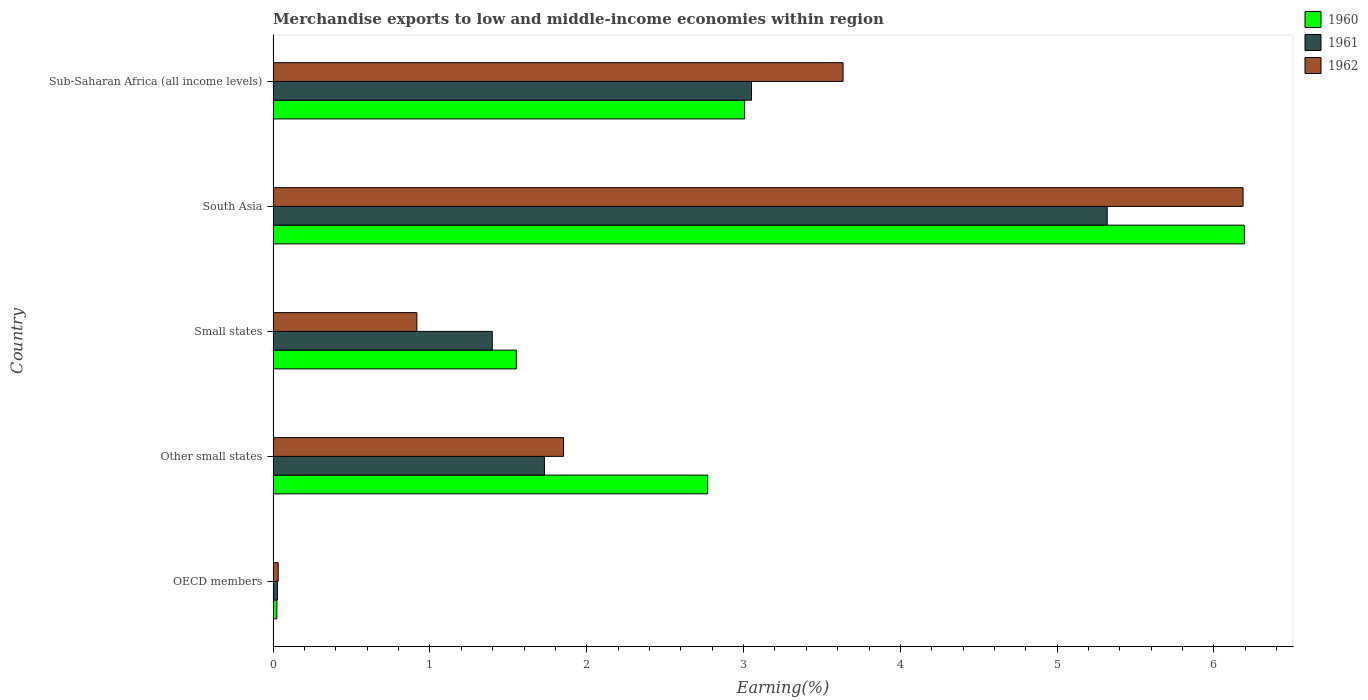How many different coloured bars are there?
Provide a succinct answer. 3. Are the number of bars per tick equal to the number of legend labels?
Your answer should be compact. Yes. Are the number of bars on each tick of the Y-axis equal?
Offer a terse response. Yes. What is the percentage of amount earned from merchandise exports in 1962 in South Asia?
Your response must be concise. 6.19. Across all countries, what is the maximum percentage of amount earned from merchandise exports in 1960?
Make the answer very short. 6.19. Across all countries, what is the minimum percentage of amount earned from merchandise exports in 1961?
Make the answer very short. 0.03. What is the total percentage of amount earned from merchandise exports in 1960 in the graph?
Keep it short and to the point. 13.55. What is the difference between the percentage of amount earned from merchandise exports in 1960 in OECD members and that in South Asia?
Ensure brevity in your answer.  -6.17. What is the difference between the percentage of amount earned from merchandise exports in 1960 in Other small states and the percentage of amount earned from merchandise exports in 1961 in South Asia?
Keep it short and to the point. -2.55. What is the average percentage of amount earned from merchandise exports in 1960 per country?
Provide a short and direct response. 2.71. What is the difference between the percentage of amount earned from merchandise exports in 1962 and percentage of amount earned from merchandise exports in 1961 in OECD members?
Your response must be concise. 0. In how many countries, is the percentage of amount earned from merchandise exports in 1962 greater than 3.4 %?
Keep it short and to the point. 2. What is the ratio of the percentage of amount earned from merchandise exports in 1962 in OECD members to that in South Asia?
Provide a short and direct response. 0.01. Is the percentage of amount earned from merchandise exports in 1962 in Other small states less than that in Sub-Saharan Africa (all income levels)?
Provide a succinct answer. Yes. What is the difference between the highest and the second highest percentage of amount earned from merchandise exports in 1961?
Offer a terse response. 2.27. What is the difference between the highest and the lowest percentage of amount earned from merchandise exports in 1961?
Your answer should be compact. 5.29. Is the sum of the percentage of amount earned from merchandise exports in 1962 in OECD members and Small states greater than the maximum percentage of amount earned from merchandise exports in 1960 across all countries?
Ensure brevity in your answer.  No. What does the 2nd bar from the bottom in Small states represents?
Your answer should be compact. 1961. Is it the case that in every country, the sum of the percentage of amount earned from merchandise exports in 1960 and percentage of amount earned from merchandise exports in 1961 is greater than the percentage of amount earned from merchandise exports in 1962?
Provide a short and direct response. Yes. Are all the bars in the graph horizontal?
Your response must be concise. Yes. Where does the legend appear in the graph?
Your answer should be compact. Top right. How many legend labels are there?
Your answer should be very brief. 3. How are the legend labels stacked?
Make the answer very short. Vertical. What is the title of the graph?
Your response must be concise. Merchandise exports to low and middle-income economies within region. Does "1971" appear as one of the legend labels in the graph?
Make the answer very short. No. What is the label or title of the X-axis?
Your answer should be compact. Earning(%). What is the label or title of the Y-axis?
Provide a succinct answer. Country. What is the Earning(%) of 1960 in OECD members?
Your answer should be very brief. 0.02. What is the Earning(%) of 1961 in OECD members?
Offer a terse response. 0.03. What is the Earning(%) of 1962 in OECD members?
Keep it short and to the point. 0.03. What is the Earning(%) of 1960 in Other small states?
Your response must be concise. 2.77. What is the Earning(%) of 1961 in Other small states?
Your answer should be very brief. 1.73. What is the Earning(%) of 1962 in Other small states?
Give a very brief answer. 1.85. What is the Earning(%) in 1960 in Small states?
Make the answer very short. 1.55. What is the Earning(%) of 1961 in Small states?
Provide a short and direct response. 1.4. What is the Earning(%) in 1962 in Small states?
Your answer should be compact. 0.92. What is the Earning(%) in 1960 in South Asia?
Offer a terse response. 6.19. What is the Earning(%) of 1961 in South Asia?
Your answer should be very brief. 5.32. What is the Earning(%) of 1962 in South Asia?
Make the answer very short. 6.19. What is the Earning(%) of 1960 in Sub-Saharan Africa (all income levels)?
Your answer should be compact. 3.01. What is the Earning(%) of 1961 in Sub-Saharan Africa (all income levels)?
Your answer should be compact. 3.05. What is the Earning(%) of 1962 in Sub-Saharan Africa (all income levels)?
Offer a terse response. 3.63. Across all countries, what is the maximum Earning(%) of 1960?
Your answer should be compact. 6.19. Across all countries, what is the maximum Earning(%) of 1961?
Offer a terse response. 5.32. Across all countries, what is the maximum Earning(%) of 1962?
Provide a short and direct response. 6.19. Across all countries, what is the minimum Earning(%) in 1960?
Keep it short and to the point. 0.02. Across all countries, what is the minimum Earning(%) of 1961?
Make the answer very short. 0.03. Across all countries, what is the minimum Earning(%) in 1962?
Your answer should be very brief. 0.03. What is the total Earning(%) in 1960 in the graph?
Your answer should be compact. 13.55. What is the total Earning(%) in 1961 in the graph?
Keep it short and to the point. 11.53. What is the total Earning(%) of 1962 in the graph?
Your answer should be very brief. 12.62. What is the difference between the Earning(%) of 1960 in OECD members and that in Other small states?
Give a very brief answer. -2.75. What is the difference between the Earning(%) in 1961 in OECD members and that in Other small states?
Provide a succinct answer. -1.7. What is the difference between the Earning(%) in 1962 in OECD members and that in Other small states?
Make the answer very short. -1.82. What is the difference between the Earning(%) in 1960 in OECD members and that in Small states?
Your answer should be compact. -1.53. What is the difference between the Earning(%) in 1961 in OECD members and that in Small states?
Give a very brief answer. -1.37. What is the difference between the Earning(%) of 1962 in OECD members and that in Small states?
Provide a short and direct response. -0.88. What is the difference between the Earning(%) in 1960 in OECD members and that in South Asia?
Provide a succinct answer. -6.17. What is the difference between the Earning(%) of 1961 in OECD members and that in South Asia?
Your response must be concise. -5.29. What is the difference between the Earning(%) of 1962 in OECD members and that in South Asia?
Your response must be concise. -6.15. What is the difference between the Earning(%) in 1960 in OECD members and that in Sub-Saharan Africa (all income levels)?
Give a very brief answer. -2.98. What is the difference between the Earning(%) of 1961 in OECD members and that in Sub-Saharan Africa (all income levels)?
Make the answer very short. -3.02. What is the difference between the Earning(%) in 1962 in OECD members and that in Sub-Saharan Africa (all income levels)?
Your response must be concise. -3.6. What is the difference between the Earning(%) of 1960 in Other small states and that in Small states?
Give a very brief answer. 1.22. What is the difference between the Earning(%) in 1961 in Other small states and that in Small states?
Ensure brevity in your answer.  0.33. What is the difference between the Earning(%) of 1962 in Other small states and that in Small states?
Your answer should be very brief. 0.94. What is the difference between the Earning(%) in 1960 in Other small states and that in South Asia?
Provide a succinct answer. -3.42. What is the difference between the Earning(%) of 1961 in Other small states and that in South Asia?
Give a very brief answer. -3.59. What is the difference between the Earning(%) in 1962 in Other small states and that in South Asia?
Offer a very short reply. -4.33. What is the difference between the Earning(%) of 1960 in Other small states and that in Sub-Saharan Africa (all income levels)?
Your response must be concise. -0.24. What is the difference between the Earning(%) of 1961 in Other small states and that in Sub-Saharan Africa (all income levels)?
Offer a very short reply. -1.32. What is the difference between the Earning(%) in 1962 in Other small states and that in Sub-Saharan Africa (all income levels)?
Your answer should be very brief. -1.78. What is the difference between the Earning(%) in 1960 in Small states and that in South Asia?
Offer a very short reply. -4.64. What is the difference between the Earning(%) in 1961 in Small states and that in South Asia?
Your answer should be very brief. -3.92. What is the difference between the Earning(%) of 1962 in Small states and that in South Asia?
Make the answer very short. -5.27. What is the difference between the Earning(%) in 1960 in Small states and that in Sub-Saharan Africa (all income levels)?
Keep it short and to the point. -1.46. What is the difference between the Earning(%) of 1961 in Small states and that in Sub-Saharan Africa (all income levels)?
Give a very brief answer. -1.65. What is the difference between the Earning(%) of 1962 in Small states and that in Sub-Saharan Africa (all income levels)?
Offer a terse response. -2.72. What is the difference between the Earning(%) of 1960 in South Asia and that in Sub-Saharan Africa (all income levels)?
Offer a terse response. 3.19. What is the difference between the Earning(%) in 1961 in South Asia and that in Sub-Saharan Africa (all income levels)?
Give a very brief answer. 2.27. What is the difference between the Earning(%) in 1962 in South Asia and that in Sub-Saharan Africa (all income levels)?
Ensure brevity in your answer.  2.55. What is the difference between the Earning(%) of 1960 in OECD members and the Earning(%) of 1961 in Other small states?
Your answer should be compact. -1.71. What is the difference between the Earning(%) in 1960 in OECD members and the Earning(%) in 1962 in Other small states?
Offer a very short reply. -1.83. What is the difference between the Earning(%) of 1961 in OECD members and the Earning(%) of 1962 in Other small states?
Provide a short and direct response. -1.82. What is the difference between the Earning(%) in 1960 in OECD members and the Earning(%) in 1961 in Small states?
Provide a succinct answer. -1.37. What is the difference between the Earning(%) of 1960 in OECD members and the Earning(%) of 1962 in Small states?
Ensure brevity in your answer.  -0.89. What is the difference between the Earning(%) of 1961 in OECD members and the Earning(%) of 1962 in Small states?
Provide a short and direct response. -0.89. What is the difference between the Earning(%) of 1960 in OECD members and the Earning(%) of 1961 in South Asia?
Provide a short and direct response. -5.3. What is the difference between the Earning(%) of 1960 in OECD members and the Earning(%) of 1962 in South Asia?
Offer a very short reply. -6.16. What is the difference between the Earning(%) in 1961 in OECD members and the Earning(%) in 1962 in South Asia?
Give a very brief answer. -6.16. What is the difference between the Earning(%) of 1960 in OECD members and the Earning(%) of 1961 in Sub-Saharan Africa (all income levels)?
Keep it short and to the point. -3.03. What is the difference between the Earning(%) in 1960 in OECD members and the Earning(%) in 1962 in Sub-Saharan Africa (all income levels)?
Offer a very short reply. -3.61. What is the difference between the Earning(%) in 1961 in OECD members and the Earning(%) in 1962 in Sub-Saharan Africa (all income levels)?
Your answer should be compact. -3.61. What is the difference between the Earning(%) of 1960 in Other small states and the Earning(%) of 1961 in Small states?
Keep it short and to the point. 1.37. What is the difference between the Earning(%) of 1960 in Other small states and the Earning(%) of 1962 in Small states?
Your response must be concise. 1.85. What is the difference between the Earning(%) in 1961 in Other small states and the Earning(%) in 1962 in Small states?
Ensure brevity in your answer.  0.81. What is the difference between the Earning(%) of 1960 in Other small states and the Earning(%) of 1961 in South Asia?
Your response must be concise. -2.55. What is the difference between the Earning(%) of 1960 in Other small states and the Earning(%) of 1962 in South Asia?
Your answer should be compact. -3.41. What is the difference between the Earning(%) in 1961 in Other small states and the Earning(%) in 1962 in South Asia?
Offer a terse response. -4.46. What is the difference between the Earning(%) of 1960 in Other small states and the Earning(%) of 1961 in Sub-Saharan Africa (all income levels)?
Provide a succinct answer. -0.28. What is the difference between the Earning(%) of 1960 in Other small states and the Earning(%) of 1962 in Sub-Saharan Africa (all income levels)?
Make the answer very short. -0.86. What is the difference between the Earning(%) in 1961 in Other small states and the Earning(%) in 1962 in Sub-Saharan Africa (all income levels)?
Keep it short and to the point. -1.9. What is the difference between the Earning(%) in 1960 in Small states and the Earning(%) in 1961 in South Asia?
Offer a terse response. -3.77. What is the difference between the Earning(%) in 1960 in Small states and the Earning(%) in 1962 in South Asia?
Offer a very short reply. -4.63. What is the difference between the Earning(%) in 1961 in Small states and the Earning(%) in 1962 in South Asia?
Keep it short and to the point. -4.79. What is the difference between the Earning(%) in 1960 in Small states and the Earning(%) in 1961 in Sub-Saharan Africa (all income levels)?
Your answer should be compact. -1.5. What is the difference between the Earning(%) in 1960 in Small states and the Earning(%) in 1962 in Sub-Saharan Africa (all income levels)?
Provide a succinct answer. -2.08. What is the difference between the Earning(%) in 1961 in Small states and the Earning(%) in 1962 in Sub-Saharan Africa (all income levels)?
Keep it short and to the point. -2.24. What is the difference between the Earning(%) of 1960 in South Asia and the Earning(%) of 1961 in Sub-Saharan Africa (all income levels)?
Offer a terse response. 3.14. What is the difference between the Earning(%) in 1960 in South Asia and the Earning(%) in 1962 in Sub-Saharan Africa (all income levels)?
Your response must be concise. 2.56. What is the difference between the Earning(%) in 1961 in South Asia and the Earning(%) in 1962 in Sub-Saharan Africa (all income levels)?
Your answer should be compact. 1.68. What is the average Earning(%) of 1960 per country?
Offer a terse response. 2.71. What is the average Earning(%) of 1961 per country?
Make the answer very short. 2.31. What is the average Earning(%) of 1962 per country?
Give a very brief answer. 2.52. What is the difference between the Earning(%) of 1960 and Earning(%) of 1961 in OECD members?
Offer a terse response. -0. What is the difference between the Earning(%) of 1960 and Earning(%) of 1962 in OECD members?
Offer a terse response. -0.01. What is the difference between the Earning(%) of 1961 and Earning(%) of 1962 in OECD members?
Offer a terse response. -0. What is the difference between the Earning(%) of 1960 and Earning(%) of 1961 in Other small states?
Offer a very short reply. 1.04. What is the difference between the Earning(%) of 1960 and Earning(%) of 1962 in Other small states?
Keep it short and to the point. 0.92. What is the difference between the Earning(%) in 1961 and Earning(%) in 1962 in Other small states?
Ensure brevity in your answer.  -0.12. What is the difference between the Earning(%) in 1960 and Earning(%) in 1961 in Small states?
Make the answer very short. 0.15. What is the difference between the Earning(%) in 1960 and Earning(%) in 1962 in Small states?
Offer a very short reply. 0.63. What is the difference between the Earning(%) of 1961 and Earning(%) of 1962 in Small states?
Keep it short and to the point. 0.48. What is the difference between the Earning(%) of 1960 and Earning(%) of 1961 in South Asia?
Your answer should be very brief. 0.88. What is the difference between the Earning(%) in 1960 and Earning(%) in 1962 in South Asia?
Provide a succinct answer. 0.01. What is the difference between the Earning(%) in 1961 and Earning(%) in 1962 in South Asia?
Offer a terse response. -0.87. What is the difference between the Earning(%) of 1960 and Earning(%) of 1961 in Sub-Saharan Africa (all income levels)?
Offer a very short reply. -0.04. What is the difference between the Earning(%) in 1960 and Earning(%) in 1962 in Sub-Saharan Africa (all income levels)?
Your response must be concise. -0.63. What is the difference between the Earning(%) in 1961 and Earning(%) in 1962 in Sub-Saharan Africa (all income levels)?
Offer a very short reply. -0.58. What is the ratio of the Earning(%) in 1960 in OECD members to that in Other small states?
Offer a very short reply. 0.01. What is the ratio of the Earning(%) in 1961 in OECD members to that in Other small states?
Your answer should be compact. 0.02. What is the ratio of the Earning(%) of 1962 in OECD members to that in Other small states?
Keep it short and to the point. 0.02. What is the ratio of the Earning(%) in 1960 in OECD members to that in Small states?
Keep it short and to the point. 0.02. What is the ratio of the Earning(%) of 1961 in OECD members to that in Small states?
Make the answer very short. 0.02. What is the ratio of the Earning(%) of 1962 in OECD members to that in Small states?
Ensure brevity in your answer.  0.04. What is the ratio of the Earning(%) in 1960 in OECD members to that in South Asia?
Provide a short and direct response. 0. What is the ratio of the Earning(%) in 1961 in OECD members to that in South Asia?
Keep it short and to the point. 0.01. What is the ratio of the Earning(%) in 1962 in OECD members to that in South Asia?
Your answer should be compact. 0.01. What is the ratio of the Earning(%) of 1960 in OECD members to that in Sub-Saharan Africa (all income levels)?
Make the answer very short. 0.01. What is the ratio of the Earning(%) of 1961 in OECD members to that in Sub-Saharan Africa (all income levels)?
Give a very brief answer. 0.01. What is the ratio of the Earning(%) in 1962 in OECD members to that in Sub-Saharan Africa (all income levels)?
Ensure brevity in your answer.  0.01. What is the ratio of the Earning(%) of 1960 in Other small states to that in Small states?
Your answer should be compact. 1.79. What is the ratio of the Earning(%) in 1961 in Other small states to that in Small states?
Provide a short and direct response. 1.24. What is the ratio of the Earning(%) in 1962 in Other small states to that in Small states?
Give a very brief answer. 2.02. What is the ratio of the Earning(%) of 1960 in Other small states to that in South Asia?
Offer a terse response. 0.45. What is the ratio of the Earning(%) of 1961 in Other small states to that in South Asia?
Your answer should be very brief. 0.33. What is the ratio of the Earning(%) in 1962 in Other small states to that in South Asia?
Keep it short and to the point. 0.3. What is the ratio of the Earning(%) of 1960 in Other small states to that in Sub-Saharan Africa (all income levels)?
Your response must be concise. 0.92. What is the ratio of the Earning(%) of 1961 in Other small states to that in Sub-Saharan Africa (all income levels)?
Provide a succinct answer. 0.57. What is the ratio of the Earning(%) of 1962 in Other small states to that in Sub-Saharan Africa (all income levels)?
Ensure brevity in your answer.  0.51. What is the ratio of the Earning(%) of 1960 in Small states to that in South Asia?
Offer a very short reply. 0.25. What is the ratio of the Earning(%) in 1961 in Small states to that in South Asia?
Ensure brevity in your answer.  0.26. What is the ratio of the Earning(%) in 1962 in Small states to that in South Asia?
Provide a succinct answer. 0.15. What is the ratio of the Earning(%) of 1960 in Small states to that in Sub-Saharan Africa (all income levels)?
Your response must be concise. 0.52. What is the ratio of the Earning(%) in 1961 in Small states to that in Sub-Saharan Africa (all income levels)?
Offer a very short reply. 0.46. What is the ratio of the Earning(%) in 1962 in Small states to that in Sub-Saharan Africa (all income levels)?
Your answer should be compact. 0.25. What is the ratio of the Earning(%) of 1960 in South Asia to that in Sub-Saharan Africa (all income levels)?
Give a very brief answer. 2.06. What is the ratio of the Earning(%) in 1961 in South Asia to that in Sub-Saharan Africa (all income levels)?
Offer a very short reply. 1.74. What is the ratio of the Earning(%) of 1962 in South Asia to that in Sub-Saharan Africa (all income levels)?
Your answer should be compact. 1.7. What is the difference between the highest and the second highest Earning(%) of 1960?
Keep it short and to the point. 3.19. What is the difference between the highest and the second highest Earning(%) in 1961?
Your response must be concise. 2.27. What is the difference between the highest and the second highest Earning(%) of 1962?
Your answer should be compact. 2.55. What is the difference between the highest and the lowest Earning(%) in 1960?
Your response must be concise. 6.17. What is the difference between the highest and the lowest Earning(%) of 1961?
Offer a very short reply. 5.29. What is the difference between the highest and the lowest Earning(%) of 1962?
Offer a very short reply. 6.15. 